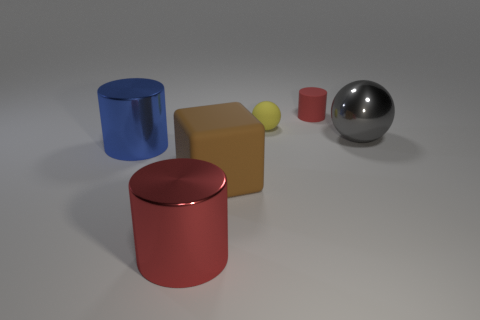What is the shape of the metal object that is the same color as the tiny cylinder?
Provide a short and direct response. Cylinder. What color is the cylinder that is behind the large brown thing and in front of the yellow thing?
Offer a terse response. Blue. Are there more spheres behind the matte ball than red rubber things?
Offer a terse response. No. Are there any matte things?
Your answer should be compact. Yes. How many small things are either gray cubes or brown blocks?
Provide a succinct answer. 0. Is there anything else of the same color as the tiny cylinder?
Your answer should be very brief. Yes. There is a small red object that is the same material as the tiny sphere; what shape is it?
Provide a succinct answer. Cylinder. How big is the yellow rubber ball that is to the left of the small red cylinder?
Your answer should be very brief. Small. The large red object is what shape?
Provide a short and direct response. Cylinder. Do the red cylinder that is to the left of the small yellow ball and the ball that is in front of the tiny yellow thing have the same size?
Your response must be concise. Yes. 